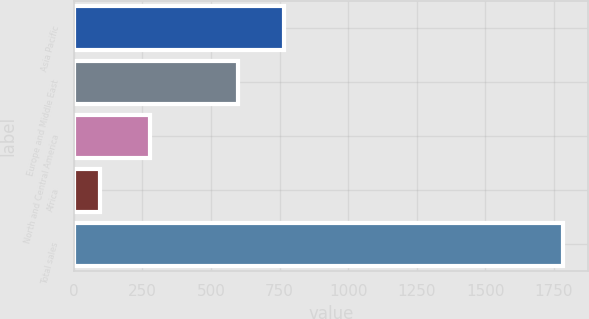<chart> <loc_0><loc_0><loc_500><loc_500><bar_chart><fcel>Asia Pacific<fcel>Europe and Middle East<fcel>North and Central America<fcel>Africa<fcel>Total sales<nl><fcel>767<fcel>598<fcel>278<fcel>94<fcel>1784<nl></chart> 